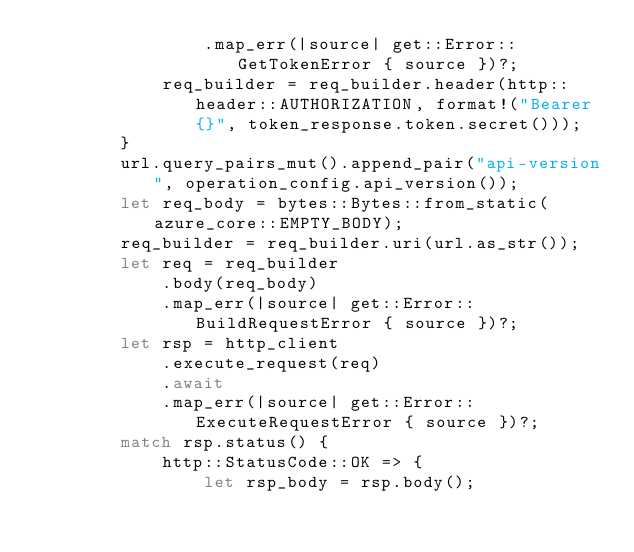Convert code to text. <code><loc_0><loc_0><loc_500><loc_500><_Rust_>                .map_err(|source| get::Error::GetTokenError { source })?;
            req_builder = req_builder.header(http::header::AUTHORIZATION, format!("Bearer {}", token_response.token.secret()));
        }
        url.query_pairs_mut().append_pair("api-version", operation_config.api_version());
        let req_body = bytes::Bytes::from_static(azure_core::EMPTY_BODY);
        req_builder = req_builder.uri(url.as_str());
        let req = req_builder
            .body(req_body)
            .map_err(|source| get::Error::BuildRequestError { source })?;
        let rsp = http_client
            .execute_request(req)
            .await
            .map_err(|source| get::Error::ExecuteRequestError { source })?;
        match rsp.status() {
            http::StatusCode::OK => {
                let rsp_body = rsp.body();</code> 